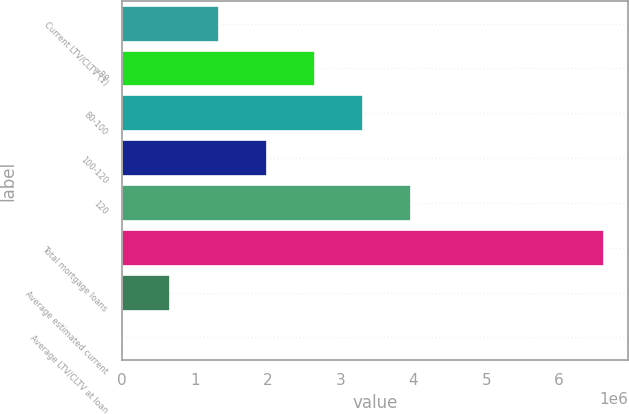Convert chart. <chart><loc_0><loc_0><loc_500><loc_500><bar_chart><fcel>Current LTV/CLTV (1)<fcel>=80<fcel>80-100<fcel>100-120<fcel>120<fcel>Total mortgage loans<fcel>Average estimated current<fcel>Average LTV/CLTV at loan<nl><fcel>1.32322e+06<fcel>2.64637e+06<fcel>3.30794e+06<fcel>1.98479e+06<fcel>3.96951e+06<fcel>6.61581e+06<fcel>661645<fcel>71<nl></chart> 